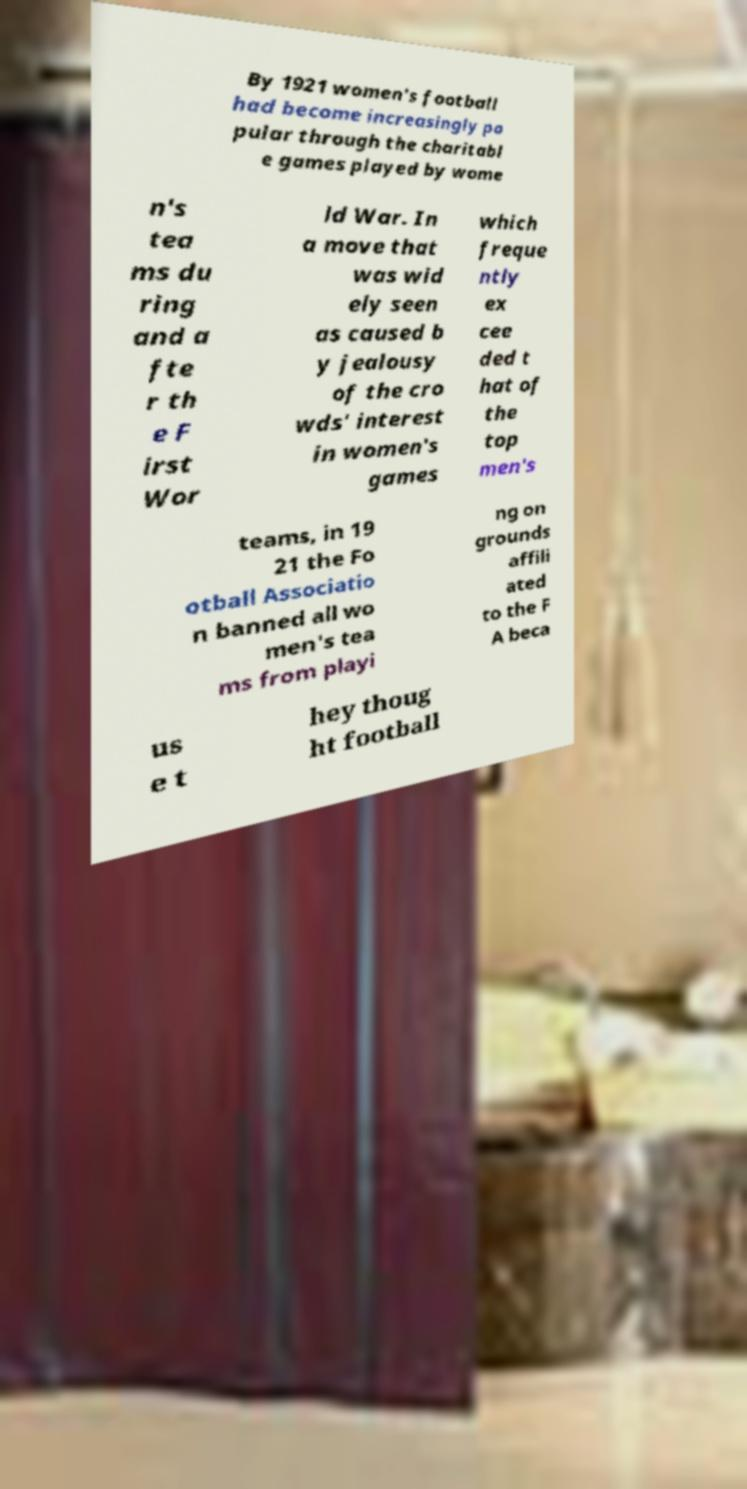What messages or text are displayed in this image? I need them in a readable, typed format. By 1921 women's football had become increasingly po pular through the charitabl e games played by wome n's tea ms du ring and a fte r th e F irst Wor ld War. In a move that was wid ely seen as caused b y jealousy of the cro wds' interest in women's games which freque ntly ex cee ded t hat of the top men's teams, in 19 21 the Fo otball Associatio n banned all wo men's tea ms from playi ng on grounds affili ated to the F A beca us e t hey thoug ht football 